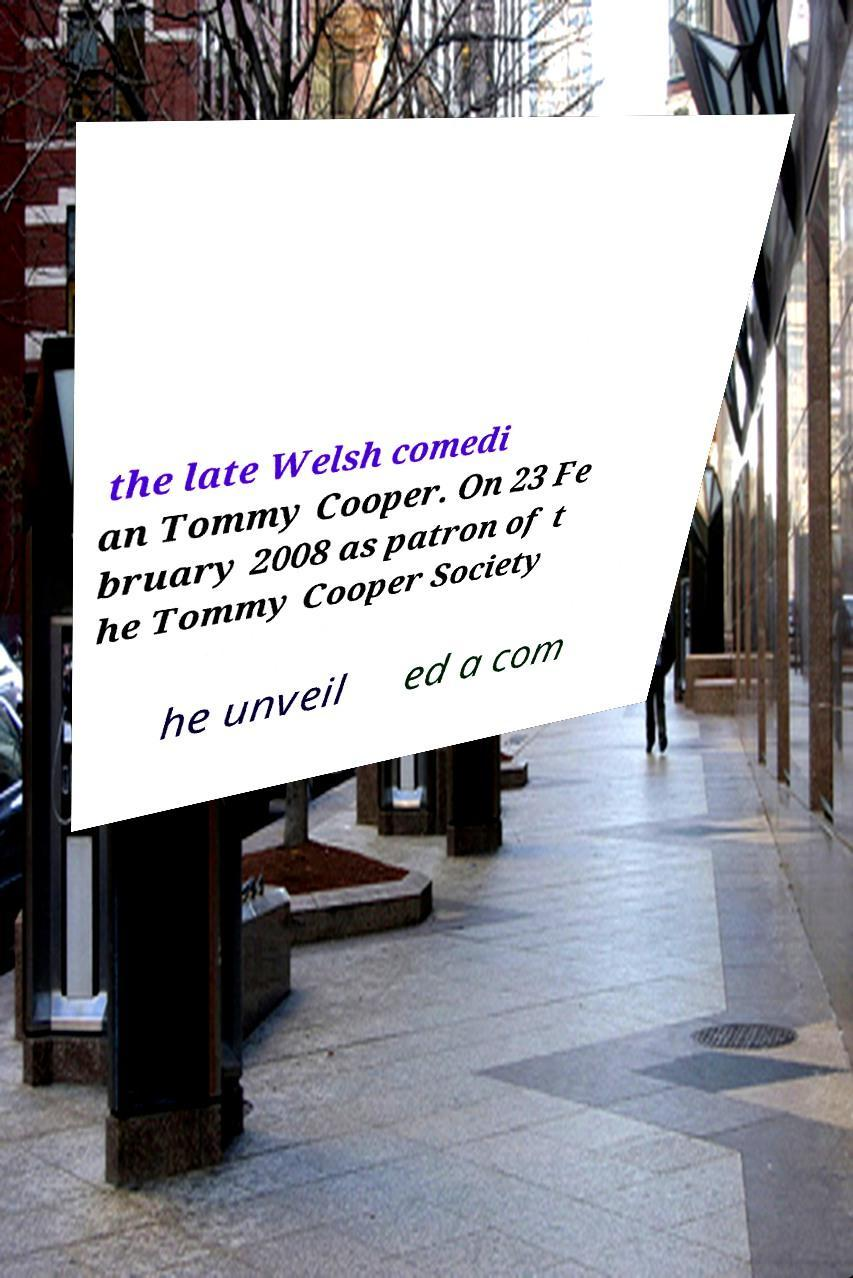I need the written content from this picture converted into text. Can you do that? the late Welsh comedi an Tommy Cooper. On 23 Fe bruary 2008 as patron of t he Tommy Cooper Society he unveil ed a com 